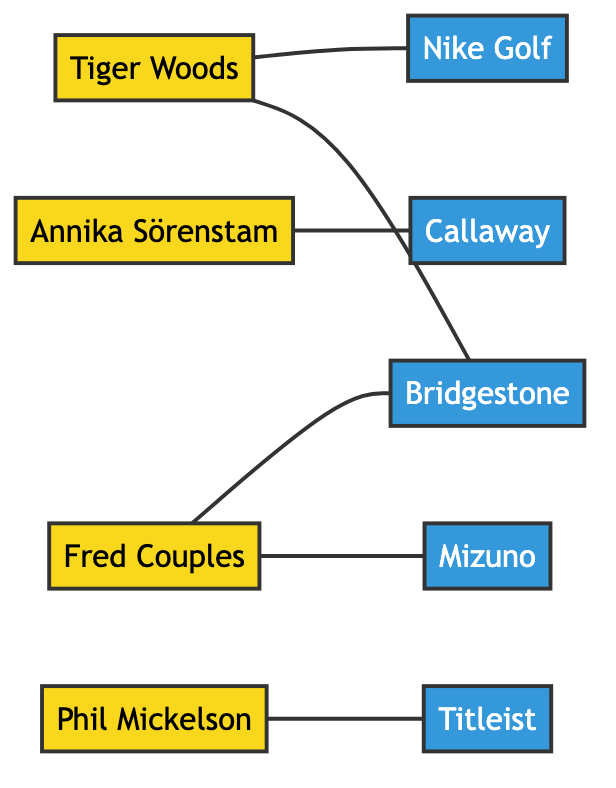What is the total number of nodes in the graph? The graph includes several individual entities known as nodes. By counting each unique entry in the nodes list, we can determine the total number of nodes. There are 9 listed nodes: Tiger Woods, Annika Sörenstam, Phil Mickelson, Fred Couples, Titleist, Callaway, Nike Golf, Bridgestone, and Mizuno.
Answer: 9 Which brand is Tiger Woods connected to? To answer this, we look at the edges connected to the Tiger Woods node. There are two edges leading from Tiger Woods: one to Nike Golf and another to Bridgestone. Hence, Tiger Woods is connected to these two brands.
Answer: Nike Golf, Bridgestone How many edges are there in total? Edges represent the connections between the nodes. By counting the entries in the edges list, we can find the total number of connections. In this case, there are 6 edges connecting the golfers to their respective brands.
Answer: 6 Which golfer is connected to Callaway? To find the golfer connected to Callaway, we inspect the edges in the diagram. The edge listed is Annika Sörenstam --- Callaway, indicating that she is the only golfer linked to this brand in the graph.
Answer: Annika Sörenstam Is there any golfer connected to more than one brand? We check the edges to see if any golfer has connections to multiple brands. By reviewing each golfer's connections, we find Tiger Woods connected to both Nike Golf and Bridgestone, demonstrating he has connections to more than one brand.
Answer: Yes, Tiger Woods Which brand has the most connections to golfers? To determine which brand is most connected, we analyze the edges and see how many golfers connect to each brand. Bridgestone is connected to two golfers: Fred Couples and Tiger Woods. Nike Golf is also connected to one golfer, while Titleist, Callaway, and Mizuno are each connected to one golfer respectively. Bridgestone stands out with the most connections.
Answer: Bridgestone Who are the two golfers connected to Bridgestone? Looking at the edges connected to Bridgestone, we identify the connections: Fred Couples is connected to Bridgestone and Tiger Woods is also connected to Bridgestone. This confirms that both golfers have ties to this brand.
Answer: Fred Couples, Tiger Woods What is the only brand connected to Phil Mickelson? We check the connections for Phil Mickelson among the edges. There is only one edge from Phil Mickelson to Titleist, showing that this is the only brand with which he has a connection in the graph.
Answer: Titleist 